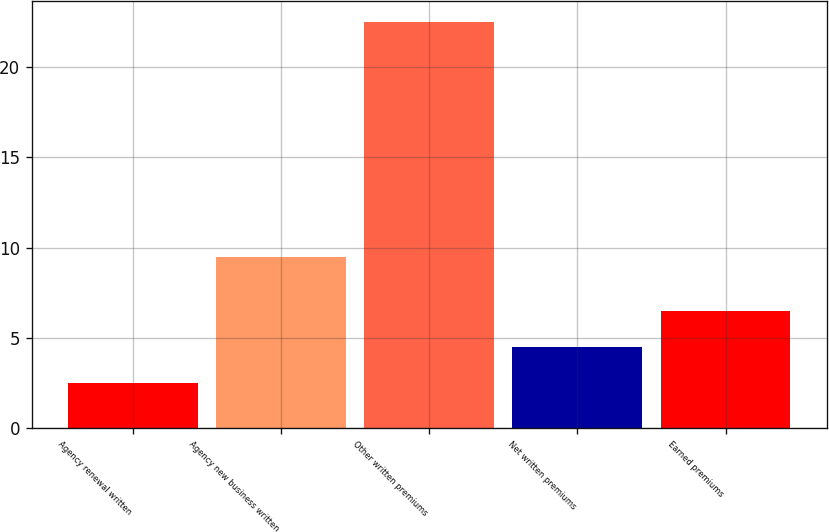Convert chart to OTSL. <chart><loc_0><loc_0><loc_500><loc_500><bar_chart><fcel>Agency renewal written<fcel>Agency new business written<fcel>Other written premiums<fcel>Net written premiums<fcel>Earned premiums<nl><fcel>2.5<fcel>9.5<fcel>22.5<fcel>4.5<fcel>6.5<nl></chart> 